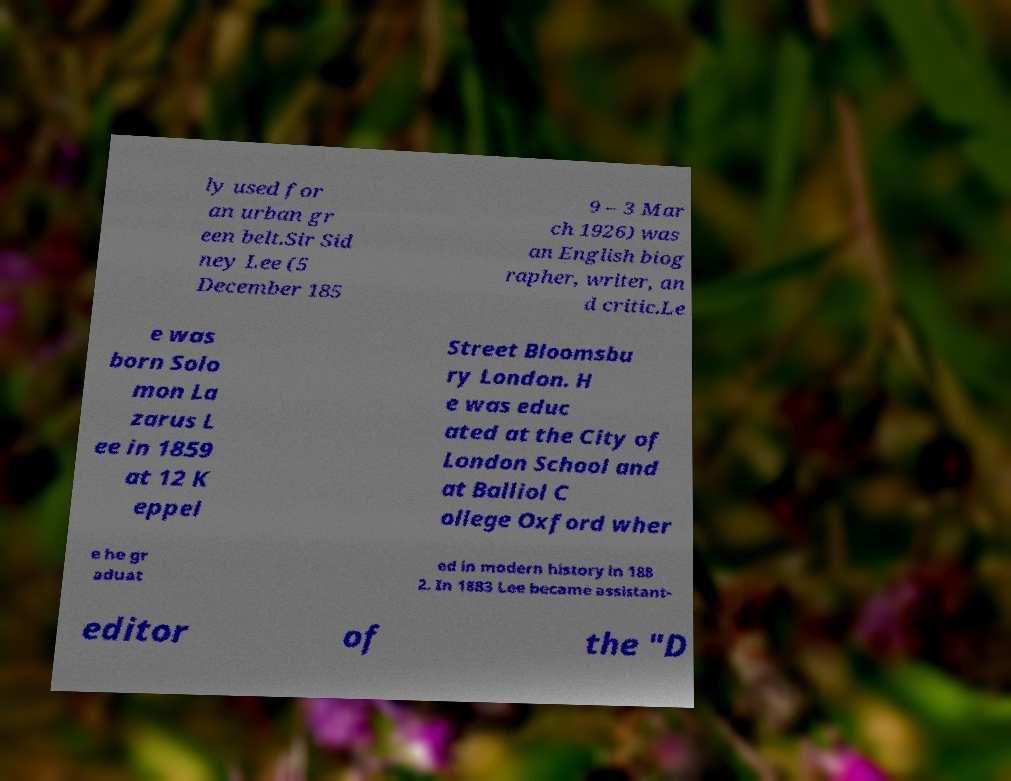I need the written content from this picture converted into text. Can you do that? ly used for an urban gr een belt.Sir Sid ney Lee (5 December 185 9 – 3 Mar ch 1926) was an English biog rapher, writer, an d critic.Le e was born Solo mon La zarus L ee in 1859 at 12 K eppel Street Bloomsbu ry London. H e was educ ated at the City of London School and at Balliol C ollege Oxford wher e he gr aduat ed in modern history in 188 2. In 1883 Lee became assistant- editor of the "D 